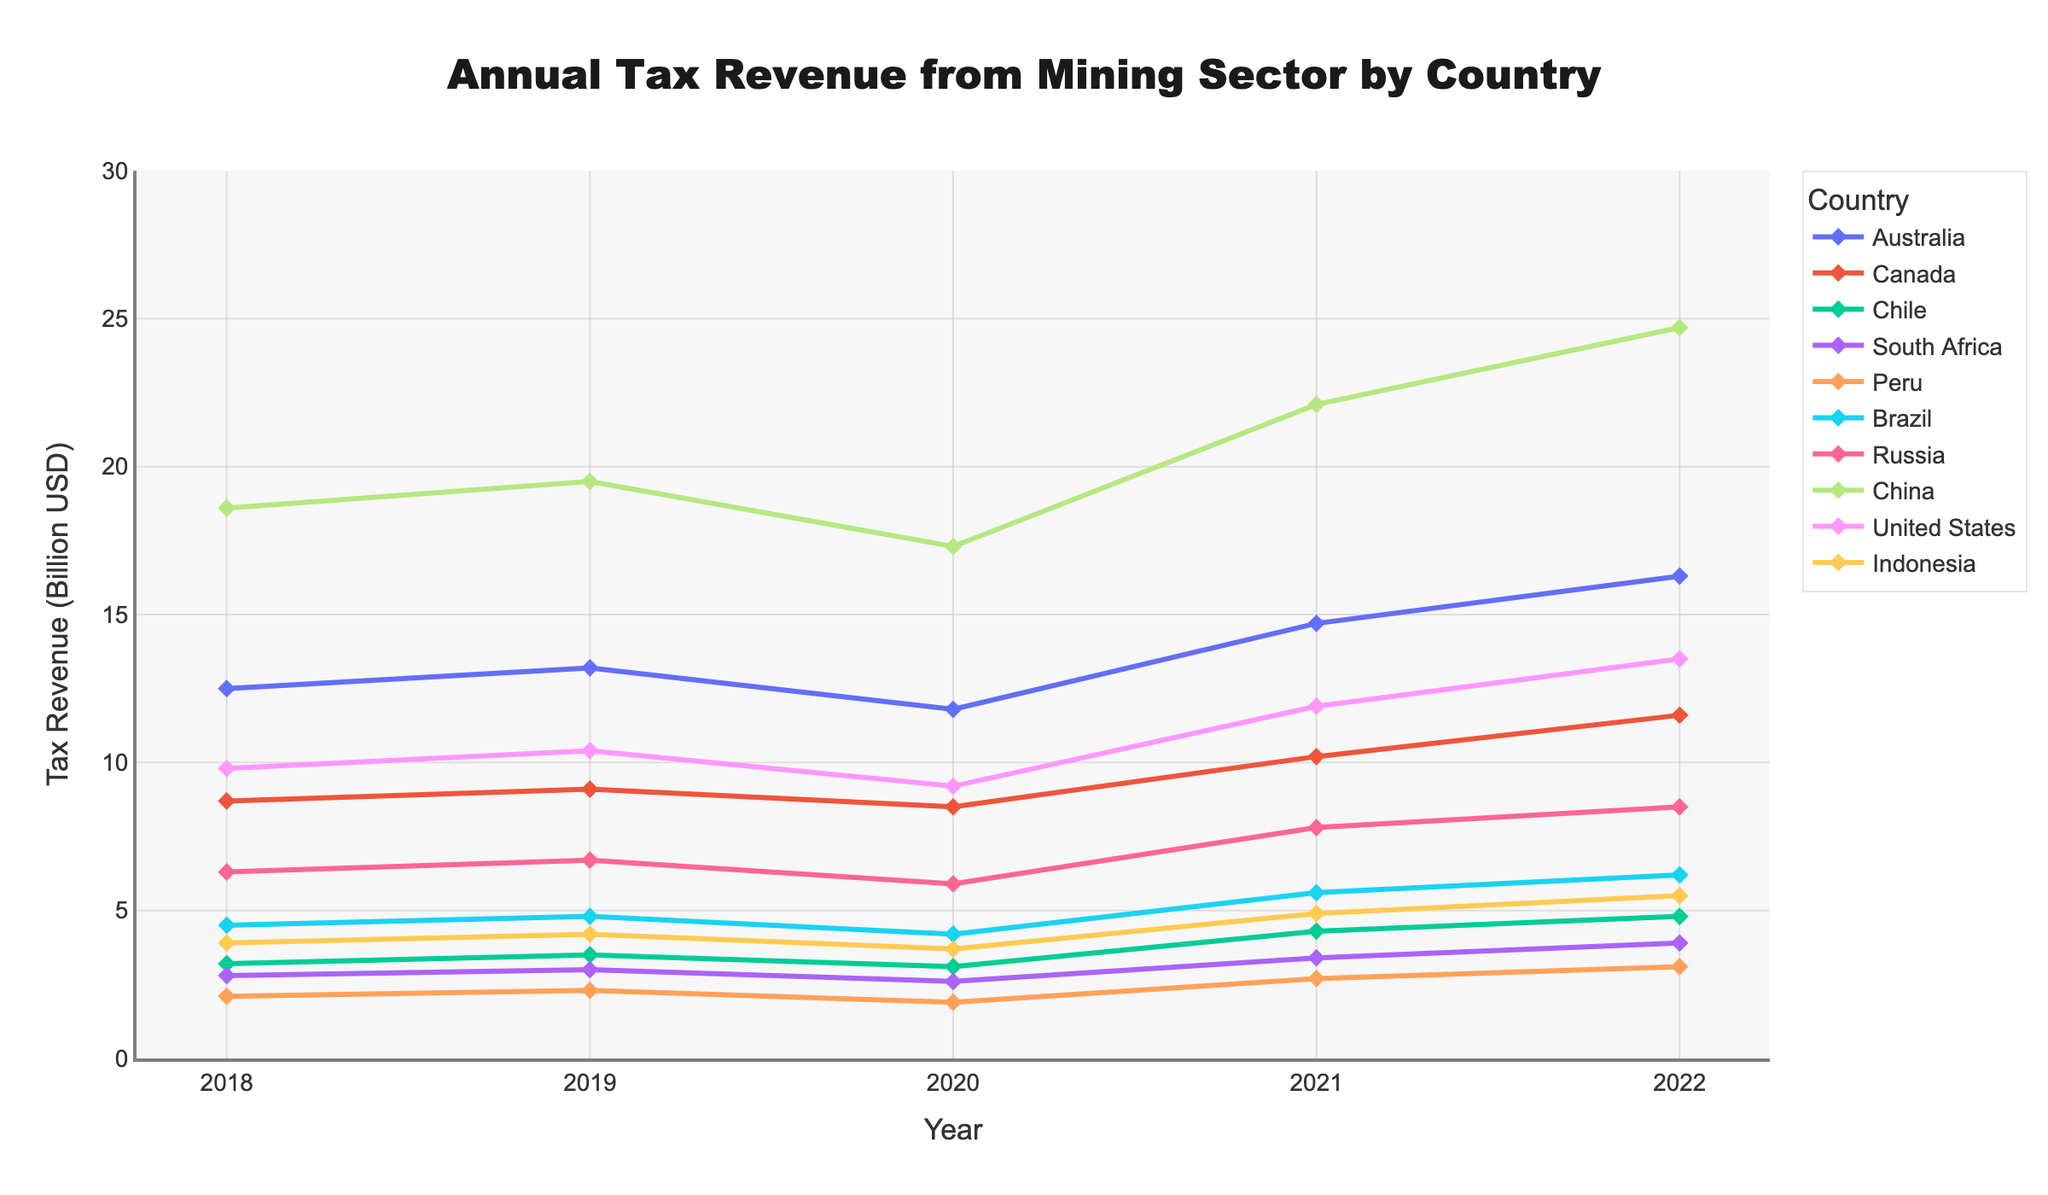What's the trend of tax revenue in China from 2018 to 2022? To determine the trend, observe the line representing China. The tax revenue in China increased from $18.6 billion in 2018 to $19.5 billion in 2019, then decreased to $17.3 billion in 2020, and subsequently increased to $22.1 billion in 2021 and $24.7 billion in 2022. The overall trend shows an increase with a dip in 2020.
Answer: Increasing with a dip in 2020 Compare the tax revenues of Australia and Canada in 2021. Which country generated more tax revenue? To compare, look at the values for 2021. Australia's tax revenue in 2021 was $14.7 billion, while Canada's was $10.2 billion. Australia generated more tax revenue than Canada in 2021.
Answer: Australia Between which years did Peru see the highest increase in tax revenue? To find this, calculate the difference in tax revenue for each consecutive year in Peru. The biggest increase is from 2020 to 2021, where the tax revenue increased from $1.9 billion to $2.7 billion, a difference of $0.8 billion.
Answer: 2020 to 2021 What is the total tax revenue generated by Brazil from 2018 to 2022? Sum up Brazil's tax revenue from each year: $4.5 billion + $4.8 billion + $4.2 billion + $5.6 billion + $6.2 billion = $25.3 billion.
Answer: $25.3 billion How does Indonesia's tax revenue in 2022 compare to its revenue in 2018? Check the visual heights and values of the markers for Indonesia in 2018 and 2022. In 2018, it's $3.9 billion, and in 2022, it's $5.5 billion. The tax revenue increased from 2018 to 2022.
Answer: Increased Which country has the least tax revenue in 2020? Check the values for all countries in 2020. Peru has the least tax revenue of $1.9 billion in 2020.
Answer: Peru In which year did South Africa experience the highest tax revenue? Look at the values for South Africa across the years. The highest tax revenue is in 2022, with $3.9 billion.
Answer: 2022 Calculate the average annual tax revenue for Chile over the five-year period from 2018 to 2022. Sum up Chile's tax revenue for each year and divide by 5: ($3.2 billion + $3.5 billion + $3.1 billion + $4.3 billion + $4.8 billion) / 5 = $18.9 billion / 5 = $3.78 billion.
Answer: $3.78 billion 